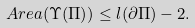<formula> <loc_0><loc_0><loc_500><loc_500>A r e a ( \Upsilon ( \Pi ) ) \leq l ( \partial \Pi ) - 2 .</formula> 